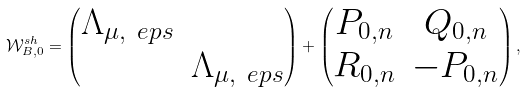Convert formula to latex. <formula><loc_0><loc_0><loc_500><loc_500>\mathcal { W } _ { B , 0 } ^ { s h } = \begin{pmatrix} \Lambda _ { \mu , \ e p s } & \\ & \Lambda _ { \mu , \ e p s } \end{pmatrix} + \begin{pmatrix} P _ { 0 , n } & Q _ { 0 , n } \\ R _ { 0 , n } & - P _ { 0 , n } \end{pmatrix} ,</formula> 